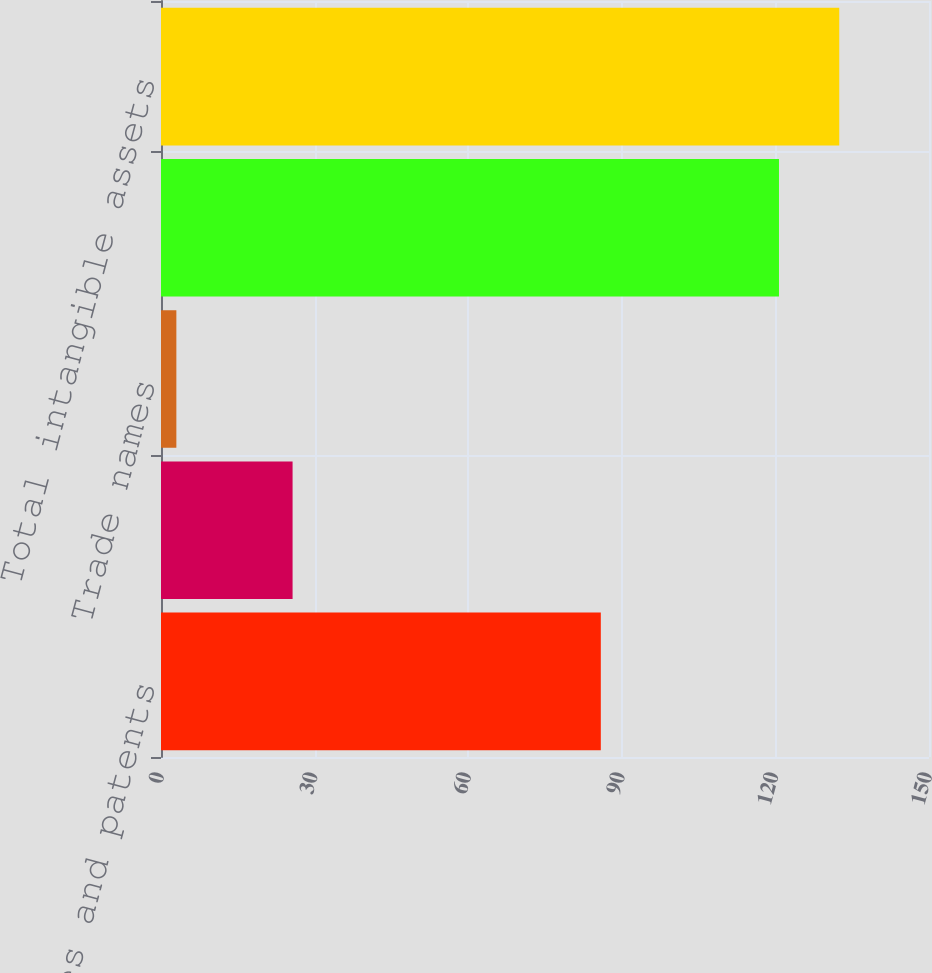<chart> <loc_0><loc_0><loc_500><loc_500><bar_chart><fcel>Technologies and patents<fcel>Customer contracts supplier<fcel>Trade names<fcel>Total intangible with finite<fcel>Total intangible assets<nl><fcel>85.9<fcel>25.7<fcel>3<fcel>120.7<fcel>132.47<nl></chart> 